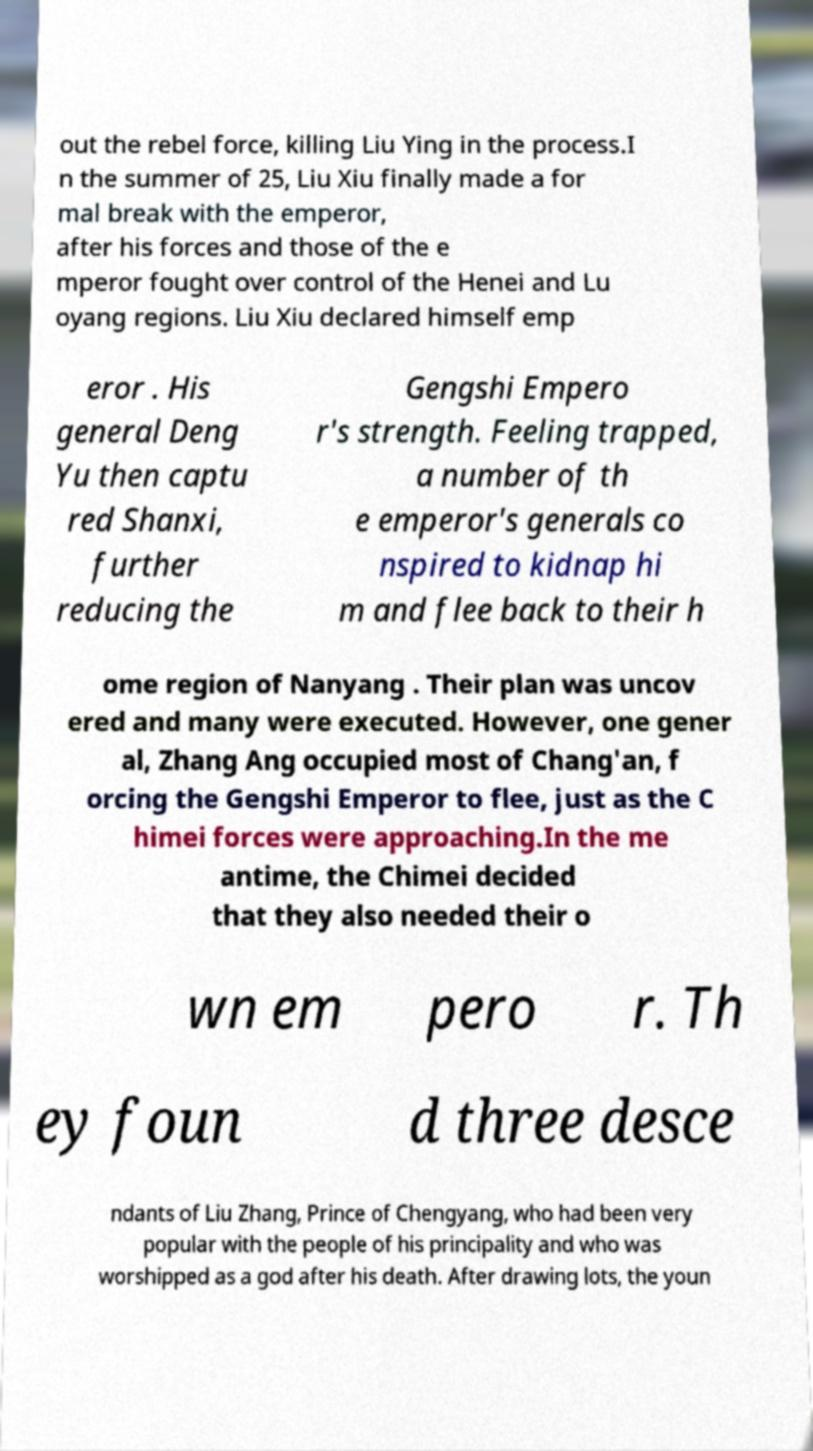What messages or text are displayed in this image? I need them in a readable, typed format. out the rebel force, killing Liu Ying in the process.I n the summer of 25, Liu Xiu finally made a for mal break with the emperor, after his forces and those of the e mperor fought over control of the Henei and Lu oyang regions. Liu Xiu declared himself emp eror . His general Deng Yu then captu red Shanxi, further reducing the Gengshi Empero r's strength. Feeling trapped, a number of th e emperor's generals co nspired to kidnap hi m and flee back to their h ome region of Nanyang . Their plan was uncov ered and many were executed. However, one gener al, Zhang Ang occupied most of Chang'an, f orcing the Gengshi Emperor to flee, just as the C himei forces were approaching.In the me antime, the Chimei decided that they also needed their o wn em pero r. Th ey foun d three desce ndants of Liu Zhang, Prince of Chengyang, who had been very popular with the people of his principality and who was worshipped as a god after his death. After drawing lots, the youn 